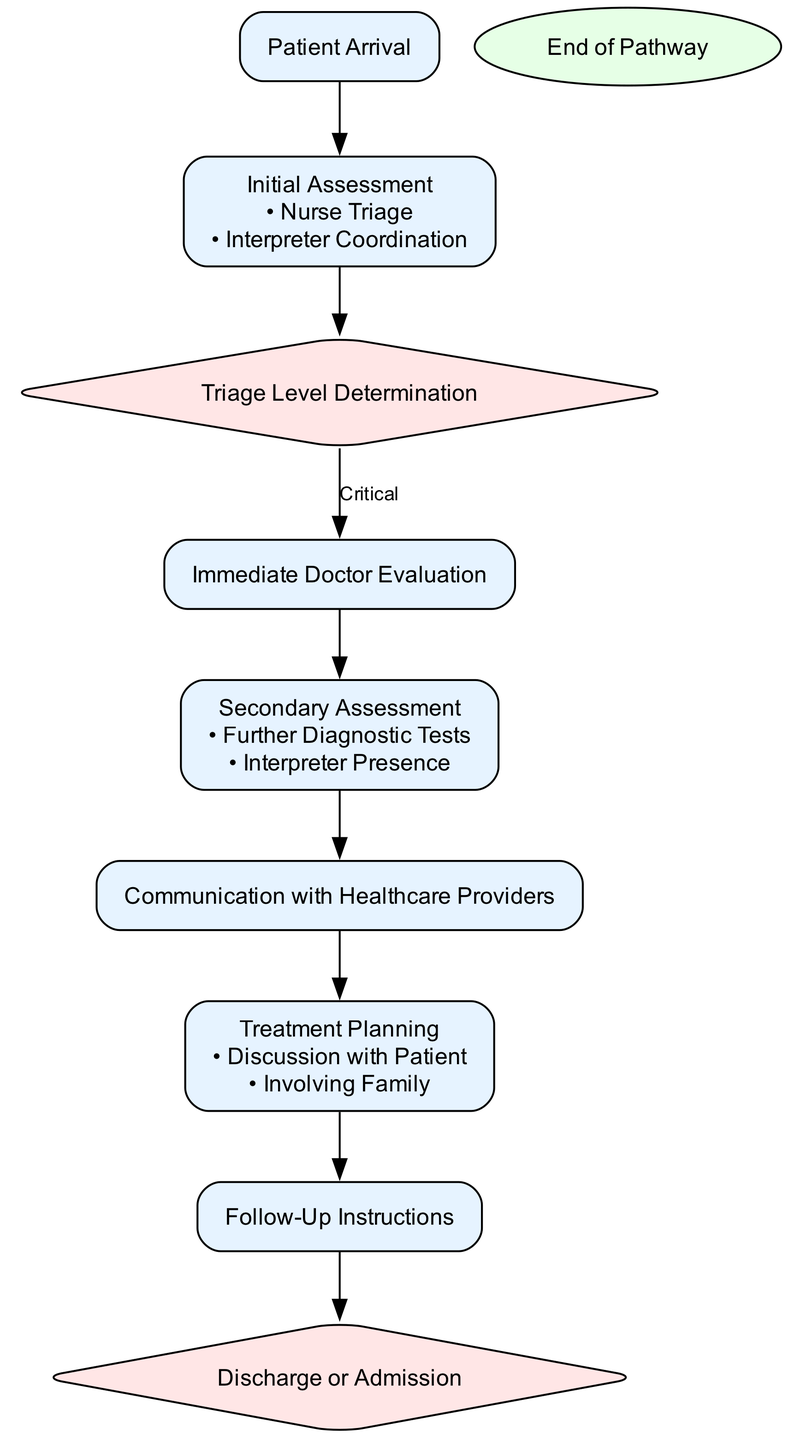What is the first step in the pathway? The first step in the pathway is "Patient Arrival". This is explicitly stated in the diagram as the initial point of the clinical pathway.
Answer: Patient Arrival How many decision nodes are present in the pathway? There are two decision nodes in the pathway: "Triage Level Determination" and "Discharge or Admission". These can be counted from their specific shapes within the diagram.
Answer: 2 What happens if a patient is determined to be critical? If a patient is determined to be critical, the next step is "Immediate Doctor Evaluation". This is shown as a direct outcome of the "Triage Level Determination" node.
Answer: Immediate Doctor Evaluation What is the purpose of interpreter coordination during assessment? The purpose of interpreter coordination during assessment is to ensure effective communication between the patient and the healthcare staff when language barriers exist. This is indicated in the "Initial Assessment" step and highlights the role of interpreters.
Answer: Ensure effective communication What follows after "Secondary Assessment" in the pathway? After "Secondary Assessment", the next step is "Communication with Healthcare Providers". The diagram outlines this flow from secondary assessment to communication to ensure clarity in the process.
Answer: Communication with Healthcare Providers What is needed during further diagnostic tests according to the pathway? An "Interpreter Presence" is needed during further diagnostic tests to assist with communication. This is clearly mentioned in the "Secondary Assessment" substeps.
Answer: Interpreter Presence How do interpreters assist after treatment planning? After treatment planning, interpreters assist by ensuring that the patient understands discharge instructions. This role is crucial for patient comprehension, as stated in the "Follow-Up Instructions" step.
Answer: Ensuring understanding of discharge instructions What action occurs if a patient is admitted? If a patient is admitted, the next action is to "Prepare for Inpatient Admission". This is indicated as an option stemming from the "Discharge or Admission" decision node in the pathway.
Answer: Prepare for Inpatient Admission What does the pathway conclude with? The pathway concludes with either "Discharge" or "Admission". This outcome is indicated in the final decision node of the pathway.
Answer: Discharge or Admission 